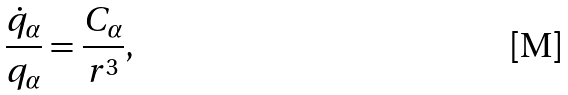Convert formula to latex. <formula><loc_0><loc_0><loc_500><loc_500>\frac { \dot { q } _ { \alpha } } { q _ { \alpha } } = \frac { C _ { \alpha } } { r ^ { 3 } } ,</formula> 